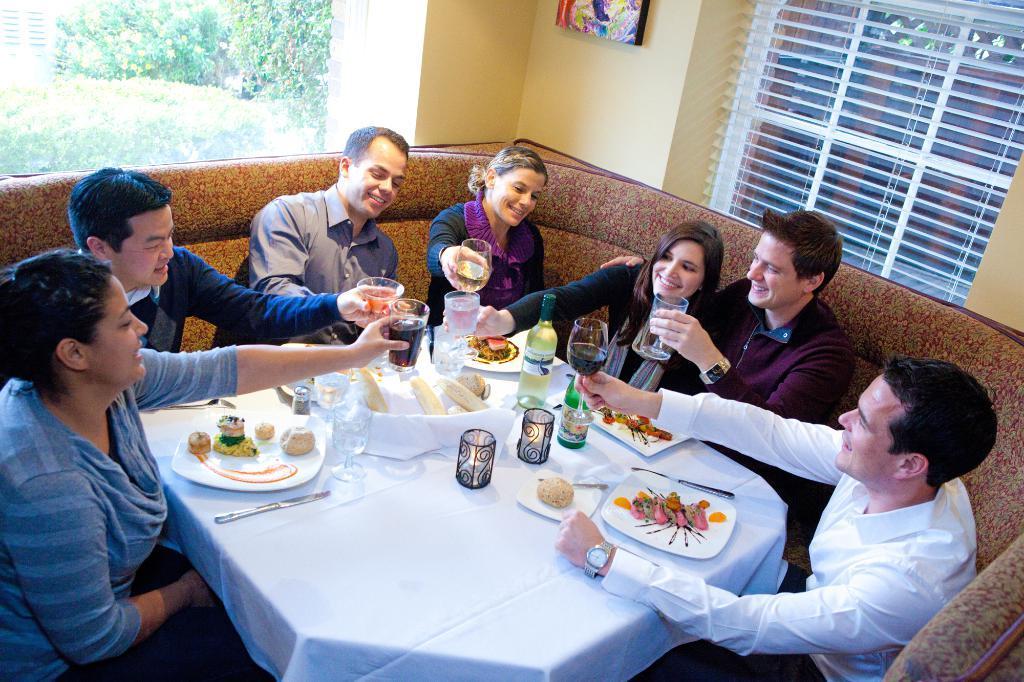Can you describe this image briefly? In this image there are group of people sitting on the couch. On the table table there is plate,food,fork,bottle and glass. The person is holding a glass. At the back side we can see trees and a building. 